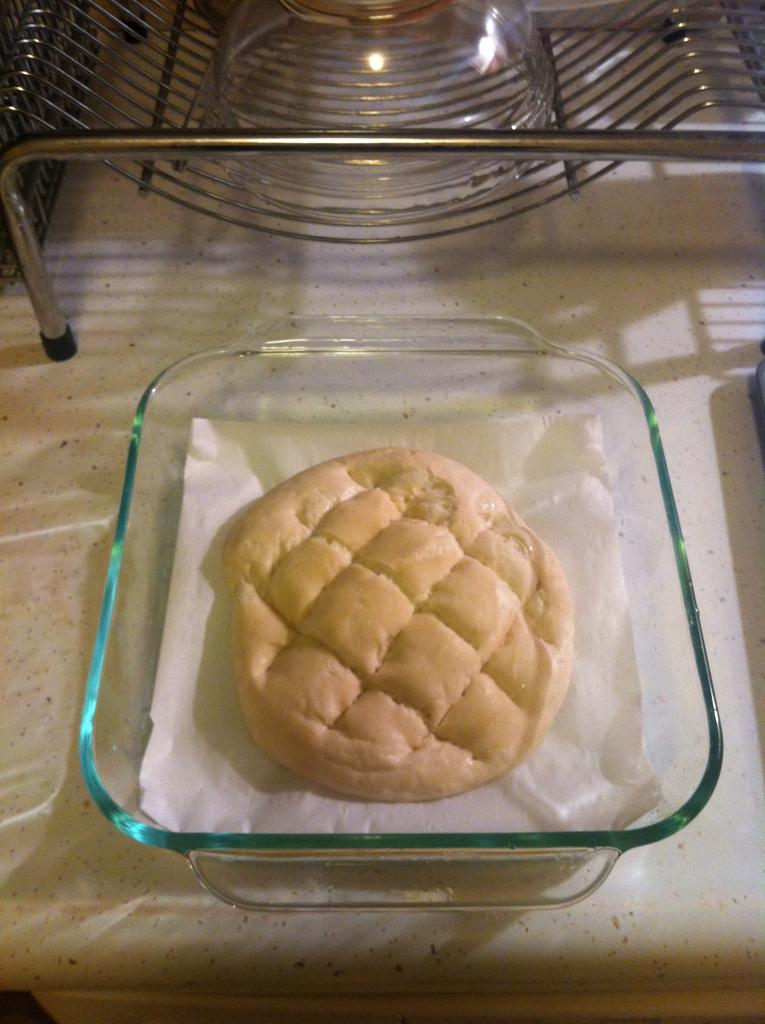What is the main subject of the image? There is an eatable item in the image. How is the eatable item contained in the image? The eatable item is in a bowl. Where is the bowl placed in the image? The bowl is placed on a table. How many pies are on the floor in the image? There are no pies present in the image, and the floor is not mentioned in the provided facts. 